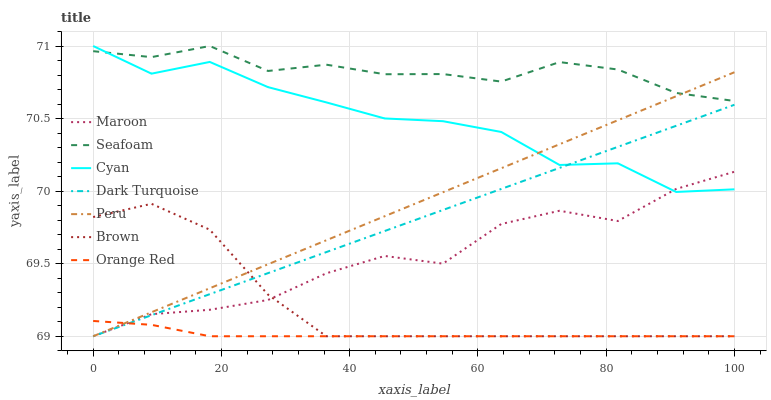Does Orange Red have the minimum area under the curve?
Answer yes or no. Yes. Does Seafoam have the maximum area under the curve?
Answer yes or no. Yes. Does Dark Turquoise have the minimum area under the curve?
Answer yes or no. No. Does Dark Turquoise have the maximum area under the curve?
Answer yes or no. No. Is Dark Turquoise the smoothest?
Answer yes or no. Yes. Is Maroon the roughest?
Answer yes or no. Yes. Is Seafoam the smoothest?
Answer yes or no. No. Is Seafoam the roughest?
Answer yes or no. No. Does Brown have the lowest value?
Answer yes or no. Yes. Does Seafoam have the lowest value?
Answer yes or no. No. Does Cyan have the highest value?
Answer yes or no. Yes. Does Dark Turquoise have the highest value?
Answer yes or no. No. Is Orange Red less than Seafoam?
Answer yes or no. Yes. Is Seafoam greater than Maroon?
Answer yes or no. Yes. Does Maroon intersect Dark Turquoise?
Answer yes or no. Yes. Is Maroon less than Dark Turquoise?
Answer yes or no. No. Is Maroon greater than Dark Turquoise?
Answer yes or no. No. Does Orange Red intersect Seafoam?
Answer yes or no. No. 